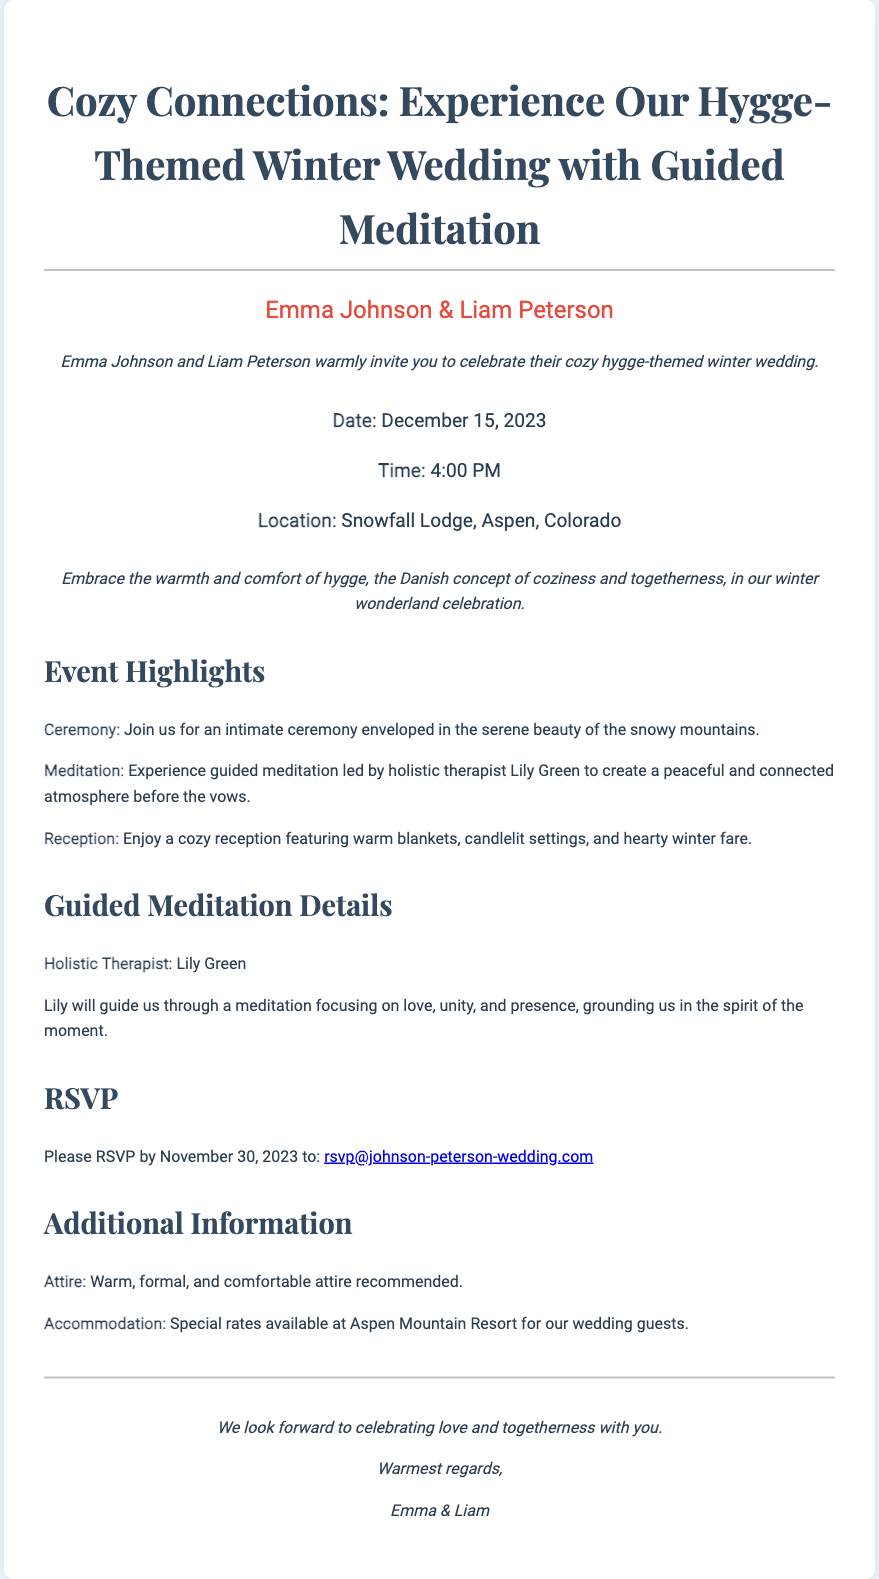what is the date of the wedding? The date of the wedding is clearly stated in the document as December 15, 2023.
Answer: December 15, 2023 who is the holistic therapist leading the meditation? The document mentions Lily Green as the holistic therapist guiding the meditation.
Answer: Lily Green what is the location of the wedding? The document specifies that the wedding will take place at Snowfall Lodge, Aspen, Colorado.
Answer: Snowfall Lodge, Aspen, Colorado what is the time of the ceremony? The document indicates that the ceremony will take place at 4:00 PM.
Answer: 4:00 PM what concept does the wedding theme embrace? The document highlights that the theme embraces the concept of hygge, which is associated with coziness and togetherness.
Answer: hygge how should guests dress for the wedding? The document advises guests to wear warm, formal, and comfortable attire.
Answer: Warm, formal, and comfortable attire how long before the wedding should guests RSVP? The document requests guests to RSVP by November 30, 2023, which is 15 days before the wedding date.
Answer: November 30, 2023 what will be included in the reception? The document lists warm blankets, candlelit settings, and hearty winter fare as features of the reception.
Answer: warm blankets, candlelit settings, and hearty winter fare what is one of the focuses of the guided meditation? The document states that the meditation will focus on love, unity, and presence.
Answer: love, unity, and presence 